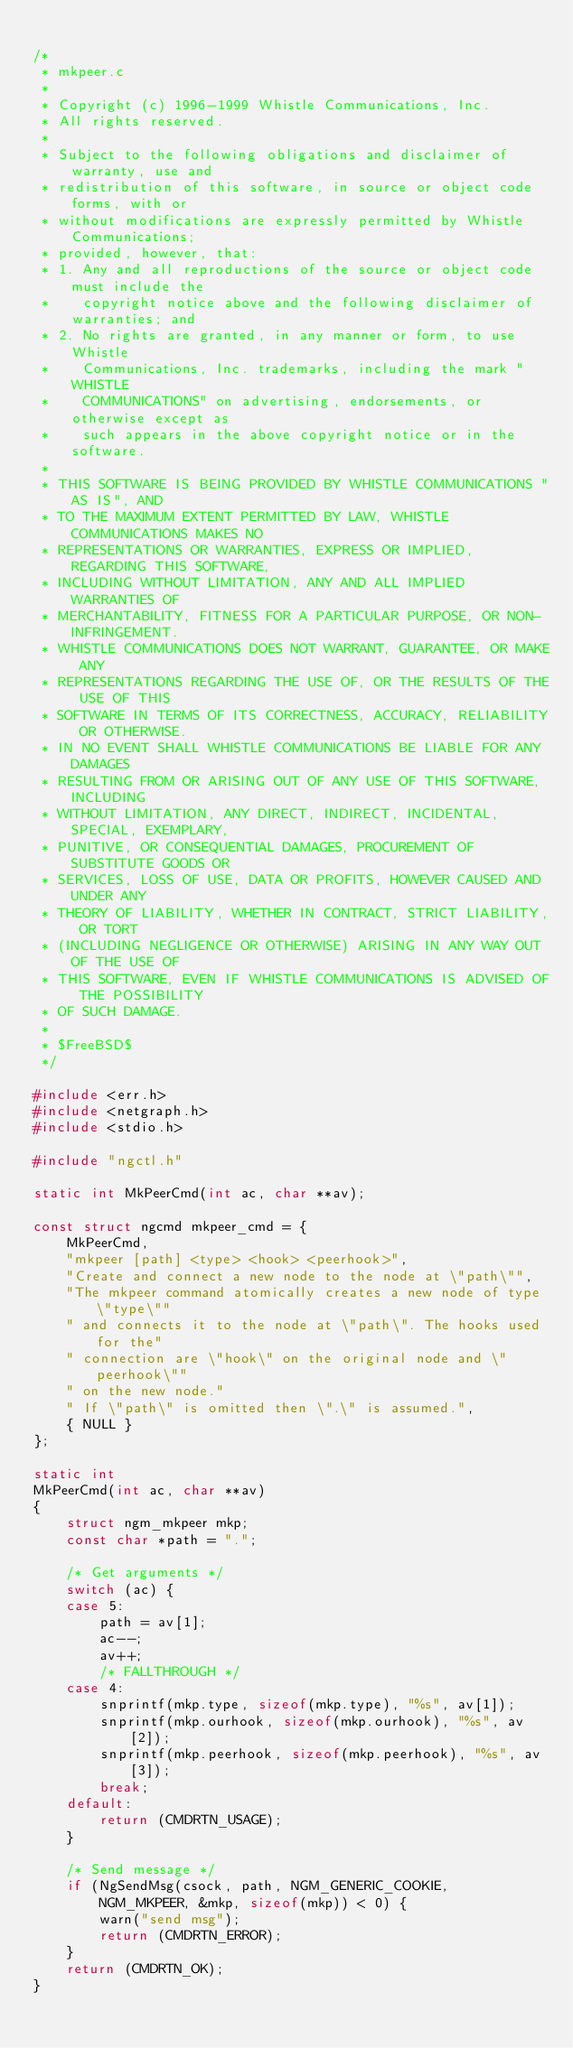Convert code to text. <code><loc_0><loc_0><loc_500><loc_500><_C_>
/*
 * mkpeer.c
 *
 * Copyright (c) 1996-1999 Whistle Communications, Inc.
 * All rights reserved.
 * 
 * Subject to the following obligations and disclaimer of warranty, use and
 * redistribution of this software, in source or object code forms, with or
 * without modifications are expressly permitted by Whistle Communications;
 * provided, however, that:
 * 1. Any and all reproductions of the source or object code must include the
 *    copyright notice above and the following disclaimer of warranties; and
 * 2. No rights are granted, in any manner or form, to use Whistle
 *    Communications, Inc. trademarks, including the mark "WHISTLE
 *    COMMUNICATIONS" on advertising, endorsements, or otherwise except as
 *    such appears in the above copyright notice or in the software.
 * 
 * THIS SOFTWARE IS BEING PROVIDED BY WHISTLE COMMUNICATIONS "AS IS", AND
 * TO THE MAXIMUM EXTENT PERMITTED BY LAW, WHISTLE COMMUNICATIONS MAKES NO
 * REPRESENTATIONS OR WARRANTIES, EXPRESS OR IMPLIED, REGARDING THIS SOFTWARE,
 * INCLUDING WITHOUT LIMITATION, ANY AND ALL IMPLIED WARRANTIES OF
 * MERCHANTABILITY, FITNESS FOR A PARTICULAR PURPOSE, OR NON-INFRINGEMENT.
 * WHISTLE COMMUNICATIONS DOES NOT WARRANT, GUARANTEE, OR MAKE ANY
 * REPRESENTATIONS REGARDING THE USE OF, OR THE RESULTS OF THE USE OF THIS
 * SOFTWARE IN TERMS OF ITS CORRECTNESS, ACCURACY, RELIABILITY OR OTHERWISE.
 * IN NO EVENT SHALL WHISTLE COMMUNICATIONS BE LIABLE FOR ANY DAMAGES
 * RESULTING FROM OR ARISING OUT OF ANY USE OF THIS SOFTWARE, INCLUDING
 * WITHOUT LIMITATION, ANY DIRECT, INDIRECT, INCIDENTAL, SPECIAL, EXEMPLARY,
 * PUNITIVE, OR CONSEQUENTIAL DAMAGES, PROCUREMENT OF SUBSTITUTE GOODS OR
 * SERVICES, LOSS OF USE, DATA OR PROFITS, HOWEVER CAUSED AND UNDER ANY
 * THEORY OF LIABILITY, WHETHER IN CONTRACT, STRICT LIABILITY, OR TORT
 * (INCLUDING NEGLIGENCE OR OTHERWISE) ARISING IN ANY WAY OUT OF THE USE OF
 * THIS SOFTWARE, EVEN IF WHISTLE COMMUNICATIONS IS ADVISED OF THE POSSIBILITY
 * OF SUCH DAMAGE.
 *
 * $FreeBSD$
 */

#include <err.h>
#include <netgraph.h>
#include <stdio.h>

#include "ngctl.h"

static int MkPeerCmd(int ac, char **av);

const struct ngcmd mkpeer_cmd = {
	MkPeerCmd,
	"mkpeer [path] <type> <hook> <peerhook>",
	"Create and connect a new node to the node at \"path\"",
	"The mkpeer command atomically creates a new node of type \"type\""
	" and connects it to the node at \"path\". The hooks used for the"
	" connection are \"hook\" on the original node and \"peerhook\""
	" on the new node."
	" If \"path\" is omitted then \".\" is assumed.",
	{ NULL }
};

static int
MkPeerCmd(int ac, char **av)
{
	struct ngm_mkpeer mkp;
	const char *path = ".";

	/* Get arguments */
	switch (ac) {
	case 5:
		path = av[1];
		ac--;
		av++;
		/* FALLTHROUGH */
	case 4:
		snprintf(mkp.type, sizeof(mkp.type), "%s", av[1]);
		snprintf(mkp.ourhook, sizeof(mkp.ourhook), "%s", av[2]);
		snprintf(mkp.peerhook, sizeof(mkp.peerhook), "%s", av[3]);
		break;
	default:
		return (CMDRTN_USAGE);
	}

	/* Send message */
	if (NgSendMsg(csock, path, NGM_GENERIC_COOKIE,
	    NGM_MKPEER, &mkp, sizeof(mkp)) < 0) {
		warn("send msg");
		return (CMDRTN_ERROR);
	}
	return (CMDRTN_OK);
}

</code> 